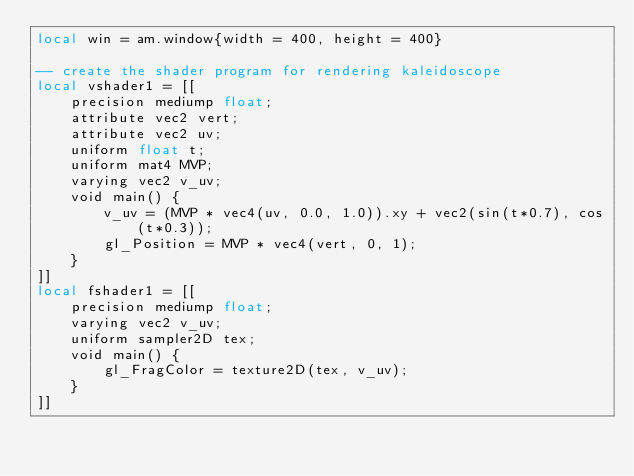Convert code to text. <code><loc_0><loc_0><loc_500><loc_500><_Lua_>local win = am.window{width = 400, height = 400}

-- create the shader program for rendering kaleidoscope
local vshader1 = [[
    precision mediump float;
    attribute vec2 vert;
    attribute vec2 uv;
    uniform float t;
    uniform mat4 MVP;
    varying vec2 v_uv;
    void main() {
        v_uv = (MVP * vec4(uv, 0.0, 1.0)).xy + vec2(sin(t*0.7), cos(t*0.3));
        gl_Position = MVP * vec4(vert, 0, 1);
    }
]]
local fshader1 = [[
    precision mediump float;
    varying vec2 v_uv;
    uniform sampler2D tex;
    void main() {
        gl_FragColor = texture2D(tex, v_uv);
    }
]]</code> 